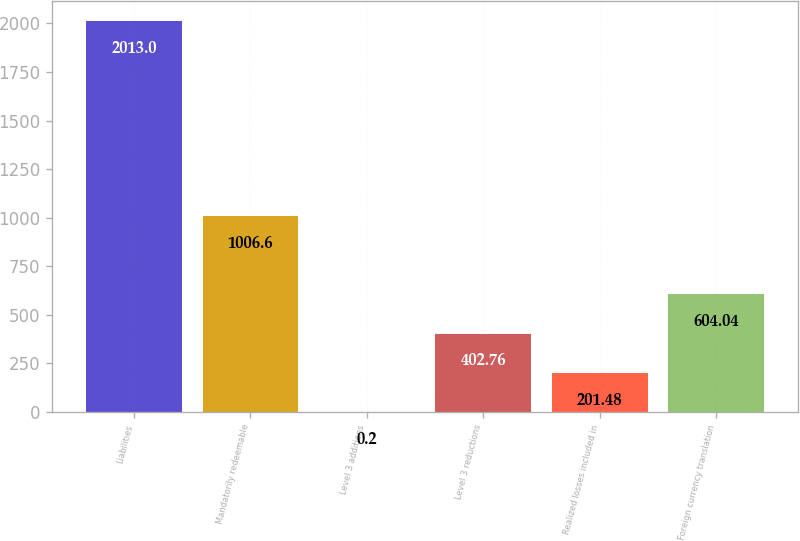Convert chart to OTSL. <chart><loc_0><loc_0><loc_500><loc_500><bar_chart><fcel>Liabilities<fcel>Mandatorily redeemable<fcel>Level 3 additions<fcel>Level 3 reductions<fcel>Realized losses included in<fcel>Foreign currency translation<nl><fcel>2013<fcel>1006.6<fcel>0.2<fcel>402.76<fcel>201.48<fcel>604.04<nl></chart> 